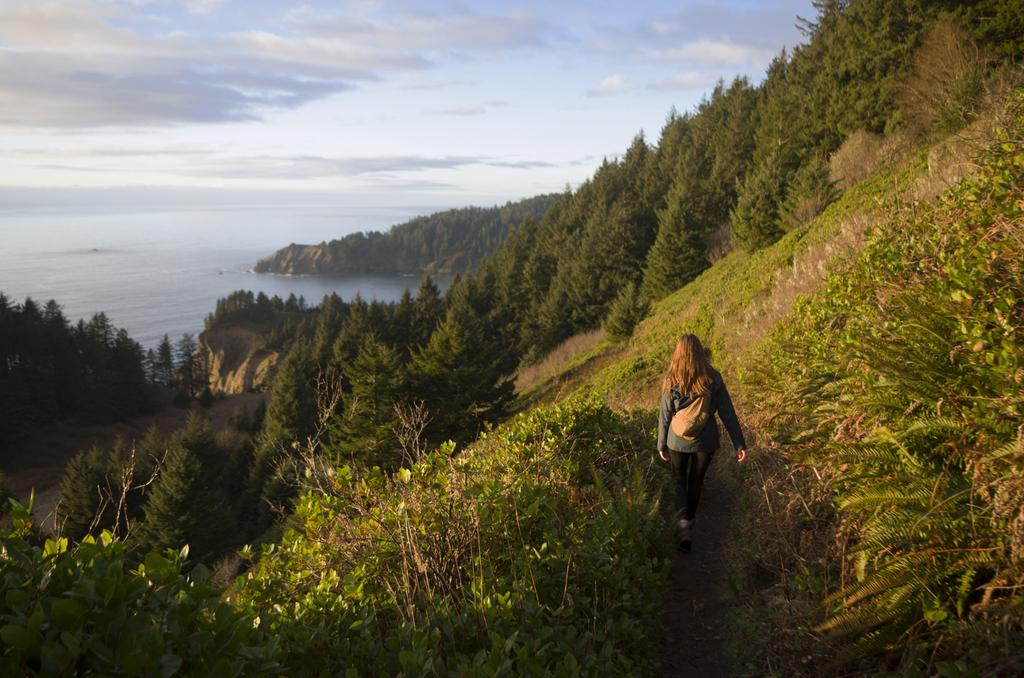Who is the main subject in the image? There is a woman in the image. What is the woman doing in the image? The woman is walking on the ground. What can be seen in the background of the image? There are trees, plants, grass, water, and the sky visible in the background of the image. What type of jewel is the woman wearing on her head in the image? There is no jewel visible on the woman's head in the image. What type of thread is being used to create the border around the image? There is no border around the image, and therefore no thread is present. 